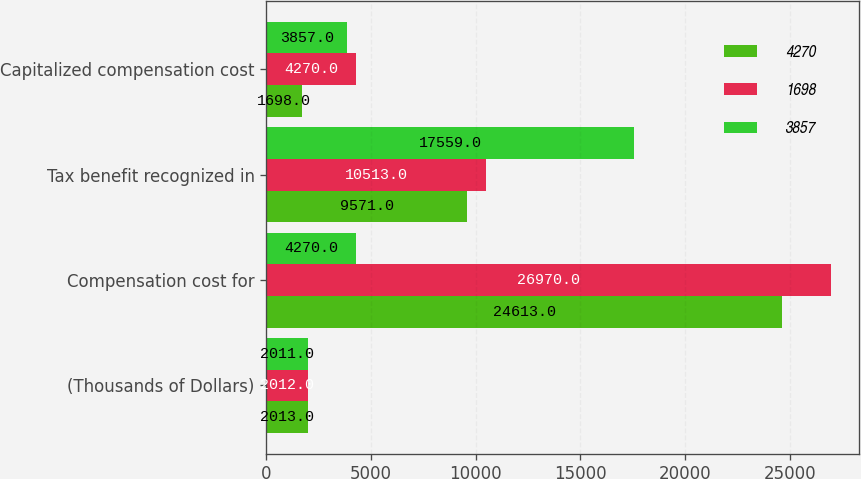Convert chart. <chart><loc_0><loc_0><loc_500><loc_500><stacked_bar_chart><ecel><fcel>(Thousands of Dollars)<fcel>Compensation cost for<fcel>Tax benefit recognized in<fcel>Capitalized compensation cost<nl><fcel>4270<fcel>2013<fcel>24613<fcel>9571<fcel>1698<nl><fcel>1698<fcel>2012<fcel>26970<fcel>10513<fcel>4270<nl><fcel>3857<fcel>2011<fcel>4270<fcel>17559<fcel>3857<nl></chart> 